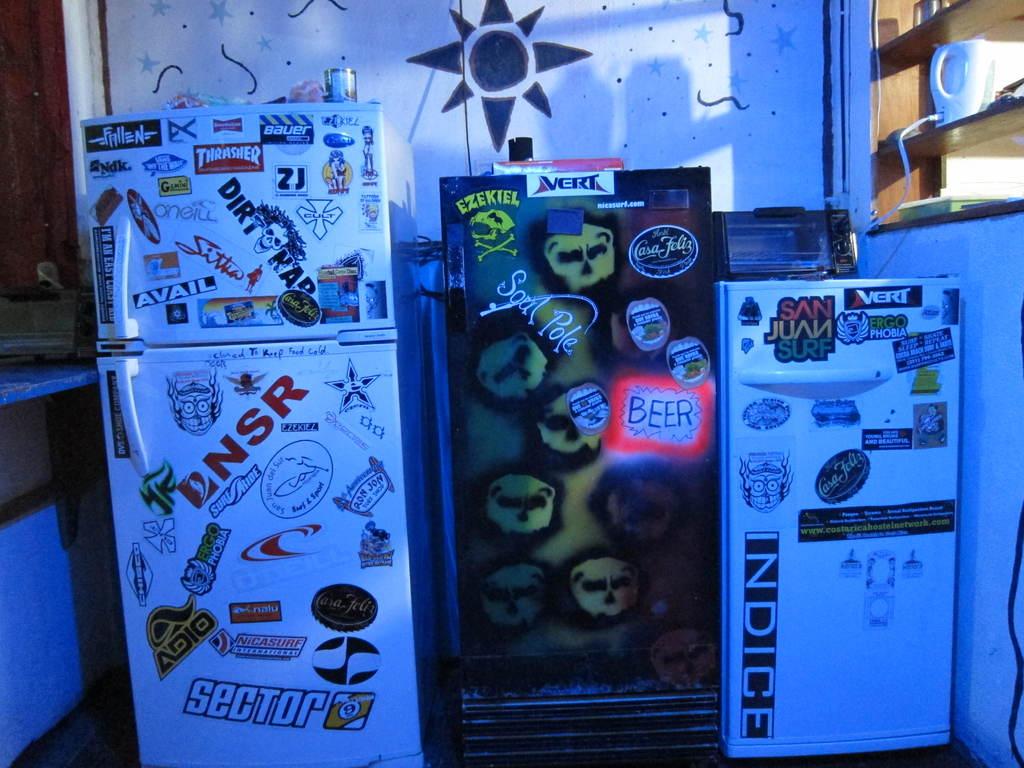What beverage is listed on the middle refrigerator?
Ensure brevity in your answer.  Beer. What does the big sticker on the top of the refrigerator on the right say?
Make the answer very short. San juan surf. 